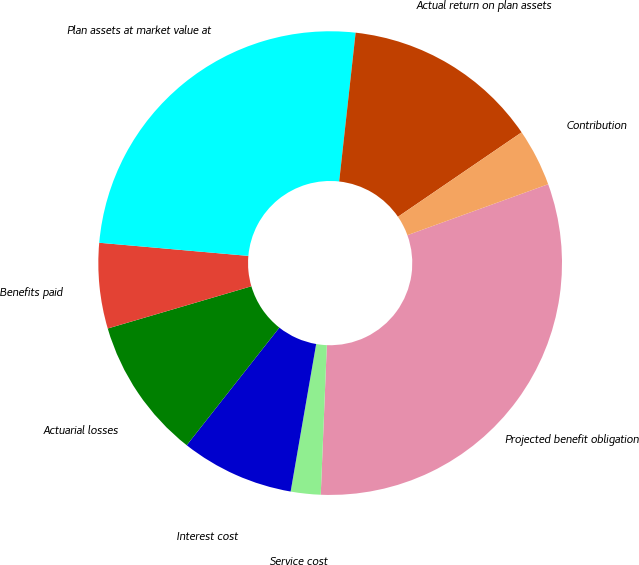Convert chart. <chart><loc_0><loc_0><loc_500><loc_500><pie_chart><fcel>Projected benefit obligation<fcel>Service cost<fcel>Interest cost<fcel>Actuarial losses<fcel>Benefits paid<fcel>Plan assets at market value at<fcel>Actual return on plan assets<fcel>Contribution<nl><fcel>31.17%<fcel>2.08%<fcel>7.89%<fcel>9.83%<fcel>5.95%<fcel>25.35%<fcel>13.71%<fcel>4.01%<nl></chart> 